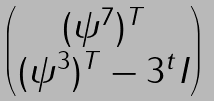<formula> <loc_0><loc_0><loc_500><loc_500>\begin{pmatrix} ( \psi ^ { 7 } ) ^ { T } \\ ( \psi ^ { 3 } ) ^ { T } - 3 ^ { t } I \end{pmatrix}</formula> 